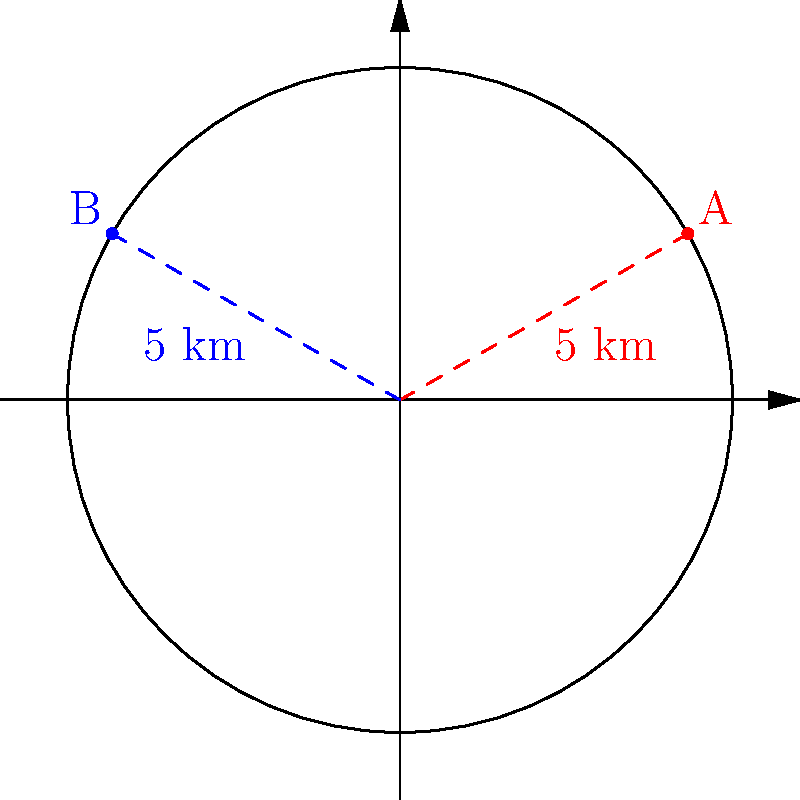As a parent concerned about cell phone coverage for your children at school, you're examining a map of local cell towers. Two towers, A and B, are located on a polar grid where each unit represents 1 km. Both towers are 5 km from the origin, with tower A at an angle of $\frac{\pi}{6}$ radians and tower B at $\frac{5\pi}{6}$ radians. What is the distance between these two towers? To solve this problem, we'll use the law of cosines for polar coordinates:

1) The formula for the distance $d$ between two points $(r_1,\theta_1)$ and $(r_2,\theta_2)$ is:

   $$d = \sqrt{r_1^2 + r_2^2 - 2r_1r_2\cos(\theta_2 - \theta_1)}$$

2) In this case:
   $r_1 = r_2 = 5$ km
   $\theta_1 = \frac{\pi}{6}$
   $\theta_2 = \frac{5\pi}{6}$

3) Substituting these values:

   $$d = \sqrt{5^2 + 5^2 - 2(5)(5)\cos(\frac{5\pi}{6} - \frac{\pi}{6})}$$

4) Simplify inside the cosine:

   $$d = \sqrt{25 + 25 - 50\cos(\frac{2\pi}{3})}$$

5) $\cos(\frac{2\pi}{3}) = -\frac{1}{2}$, so:

   $$d = \sqrt{50 + 50(\frac{1}{2})} = \sqrt{75} = 5\sqrt{3}$$

Therefore, the distance between the two towers is $5\sqrt{3}$ km.
Answer: $5\sqrt{3}$ km 